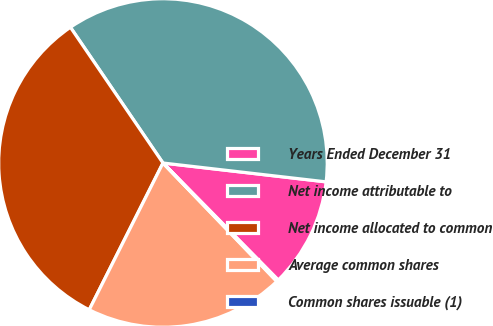Convert chart to OTSL. <chart><loc_0><loc_0><loc_500><loc_500><pie_chart><fcel>Years Ended December 31<fcel>Net income attributable to<fcel>Net income allocated to common<fcel>Average common shares<fcel>Common shares issuable (1)<nl><fcel>10.79%<fcel>36.36%<fcel>33.07%<fcel>19.6%<fcel>0.19%<nl></chart> 